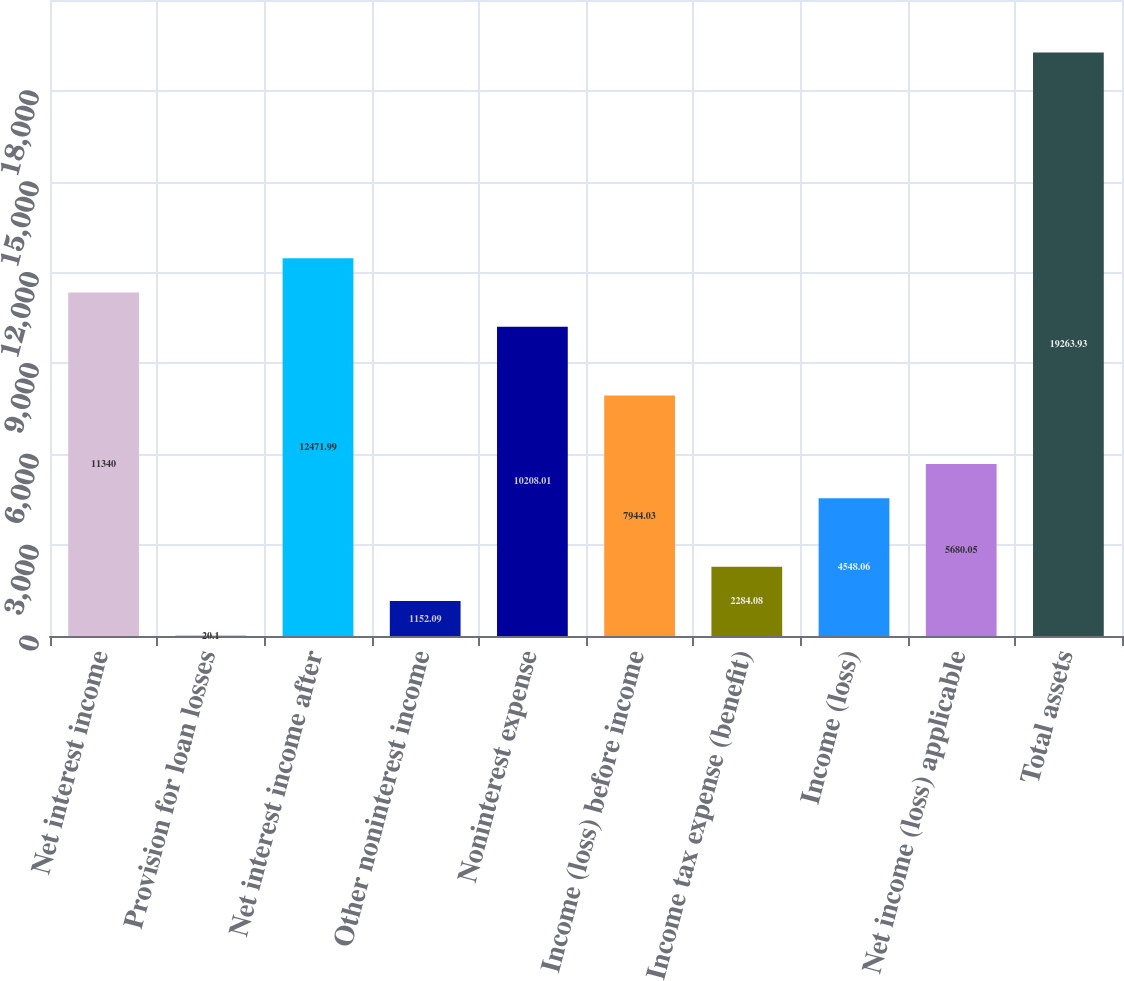Convert chart. <chart><loc_0><loc_0><loc_500><loc_500><bar_chart><fcel>Net interest income<fcel>Provision for loan losses<fcel>Net interest income after<fcel>Other noninterest income<fcel>Noninterest expense<fcel>Income (loss) before income<fcel>Income tax expense (benefit)<fcel>Income (loss)<fcel>Net income (loss) applicable<fcel>Total assets<nl><fcel>11340<fcel>20.1<fcel>12472<fcel>1152.09<fcel>10208<fcel>7944.03<fcel>2284.08<fcel>4548.06<fcel>5680.05<fcel>19263.9<nl></chart> 